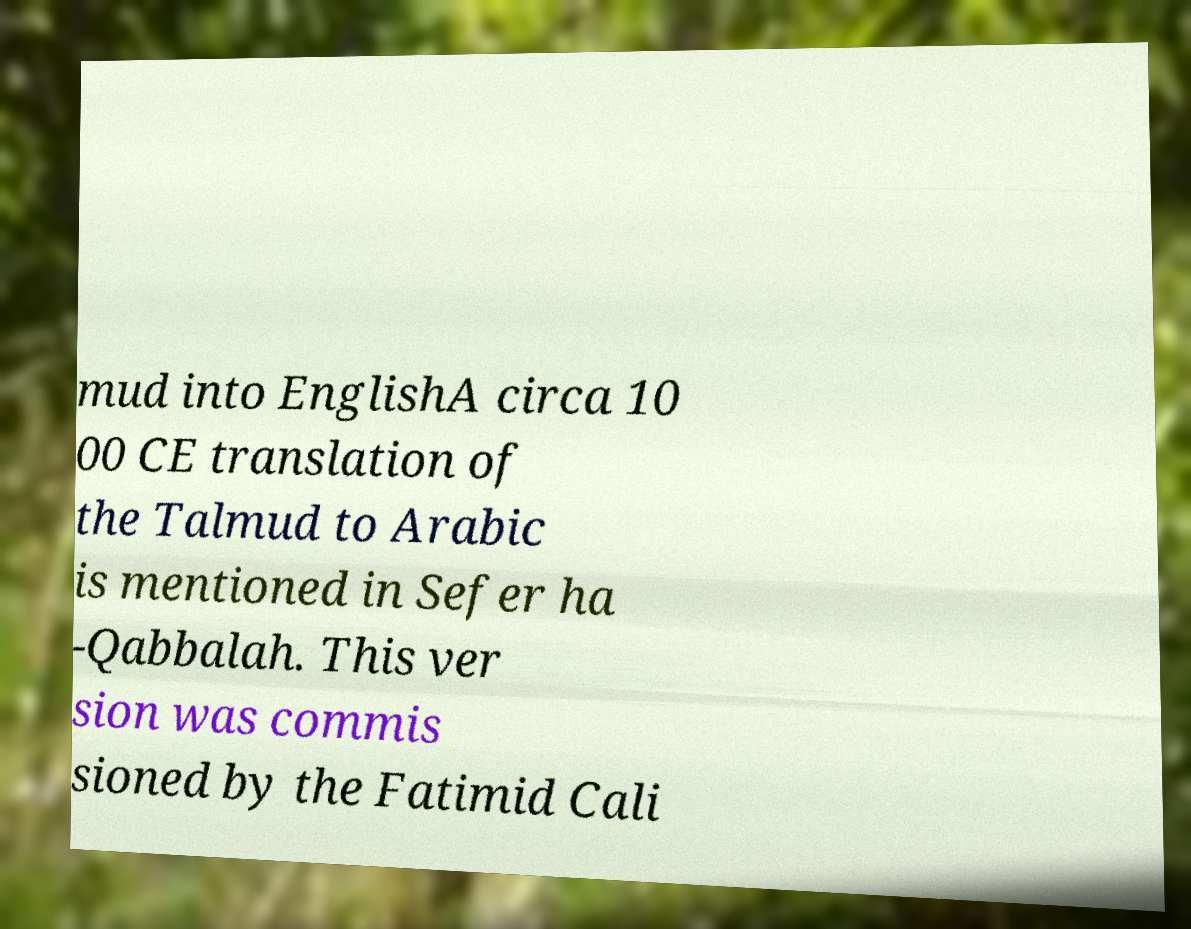Could you assist in decoding the text presented in this image and type it out clearly? mud into EnglishA circa 10 00 CE translation of the Talmud to Arabic is mentioned in Sefer ha -Qabbalah. This ver sion was commis sioned by the Fatimid Cali 